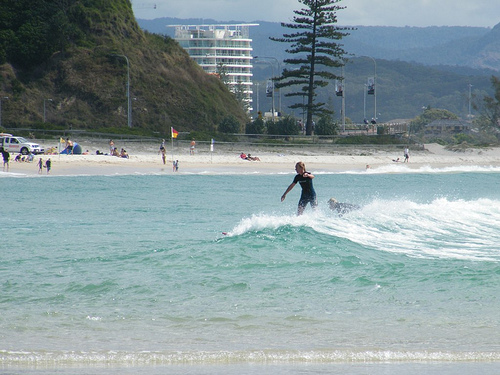What time of day does this image appear to be taken? The image appears to be taken during daytime hours, characterized by bright, clear lighting and sunny conditions typical of a beach scene in the late morning or early afternoon. 